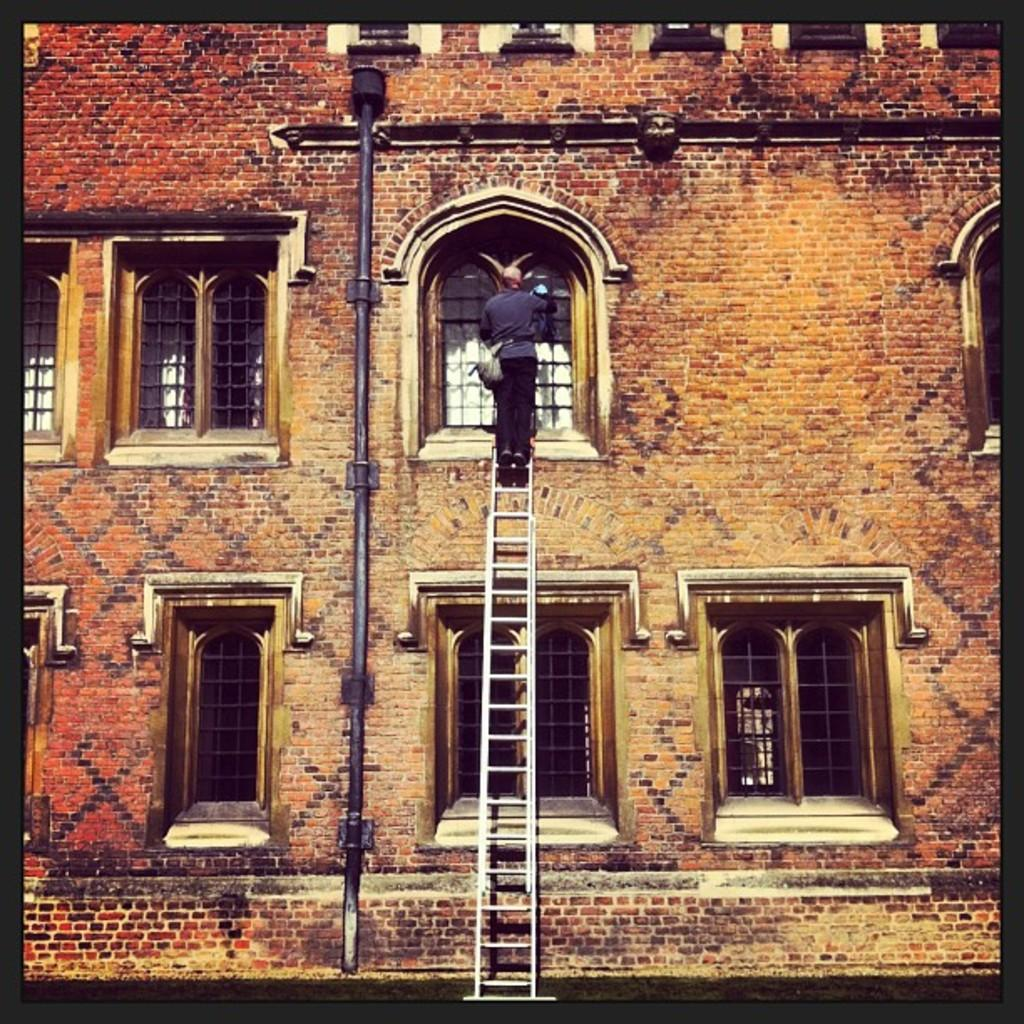What type of structure is visible in the image? There is a building in the image. What feature can be observed on the building? The building has glass windows. Can you describe the activity taking place near the building? There is a person on a ladder in the image. What type of suit is the person on the ladder wearing in the image? There is no information about the person's clothing in the image, so we cannot determine if they are wearing a suit or any other type of clothing. 